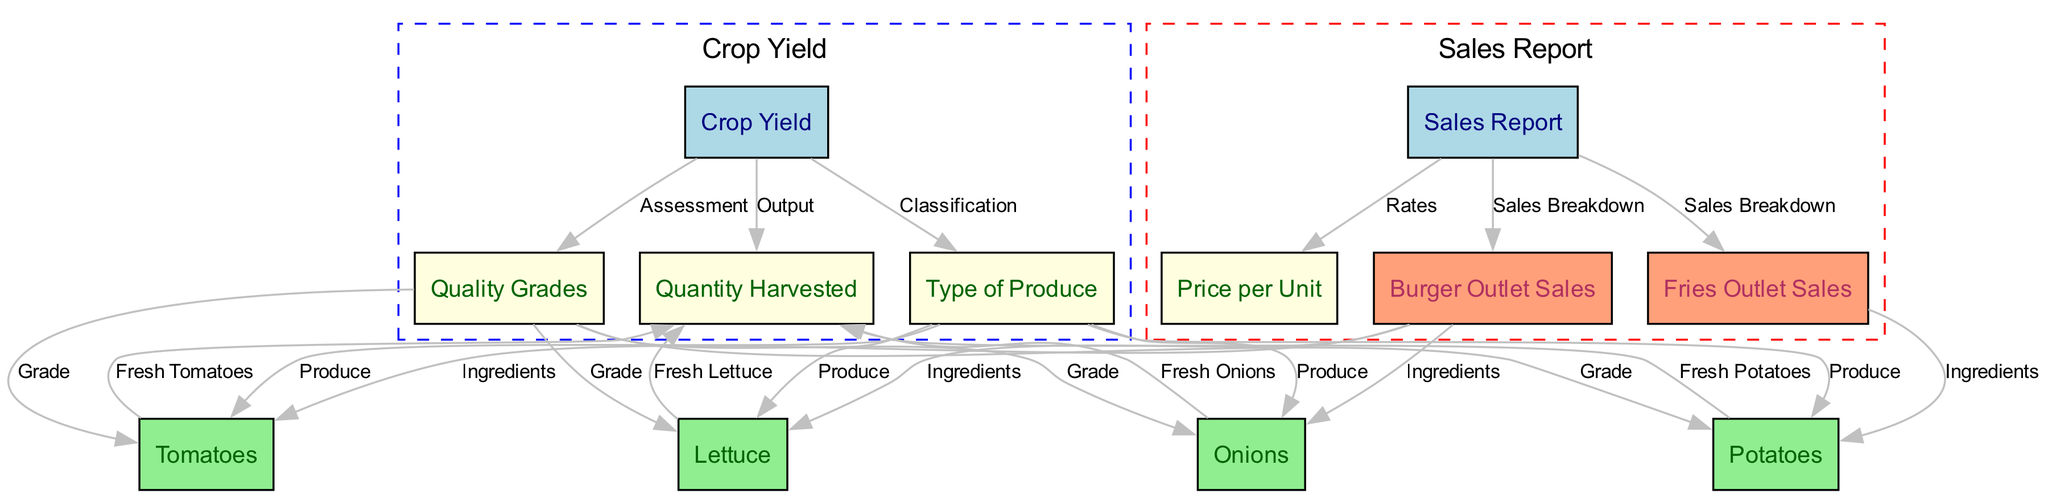What types of produce are included in the crop yield? The diagram shows that the types of produce included are lettuce, tomatoes, potatoes, and onions, as indicated under the "Type of Produce" node.
Answer: Lettuce, Tomatoes, Potatoes, Onions How is quality assessed in the crop yield? The "Quality Grades" node is connected to the "Crop Yield" node, indicating that quality assessment is a part of the crop yield evaluation process.
Answer: Assessment What is the relationship between burger outlet sales and fresh tomatoes? The diagram shows that "Burger Outlet Sales" node has a direct connection to the "Tomatoes" node, indicating that fresh tomatoes are an ingredient in burger sales.
Answer: Ingredients How many nodes are related to sales in the diagram? The related nodes are "Sales Report," "Price per Unit," "Burger Outlet Sales," and "Fries Outlet Sales," totaling four nodes.
Answer: Four What produces fresh onions? The diagram connects "Onions" to "Quantity Harvested," indicating that "Quantity Harvested" refers to the fresh onions produced.
Answer: Fresh Onions Which outlet sales correspond to fresh potatoes? "Fries Outlet Sales" is directly connected to "Potatoes" in the diagram, indicating that fresh potatoes are sold through fries outlet sales.
Answer: Fries Outlet Sales What output category is associated with crop yield? The "Quantity Harvested" node is linked to the "Crop Yield" node, showing that it is an output category related to crop yield.
Answer: Output What type of sales are detailed in the sales report? The diagram includes "Burger Outlet Sales" and "Fries Outlet Sales" as the types of sales detailed in the sales report section.
Answer: Sales Breakdown What color represents the produce types in the diagram? The produce types such as lettuce, tomatoes, potatoes, and onions are represented with a light green color in the diagram.
Answer: Light Green 